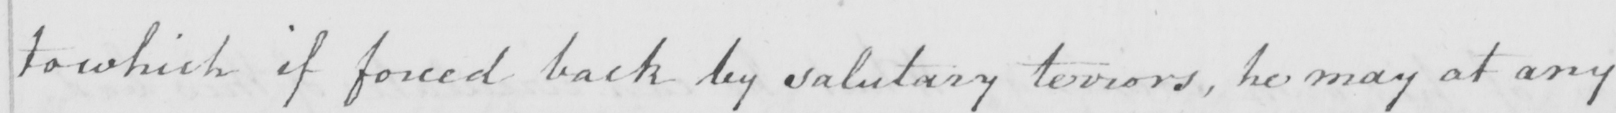Transcribe the text shown in this historical manuscript line. to which if forced back by salutary terrors , he may at any 